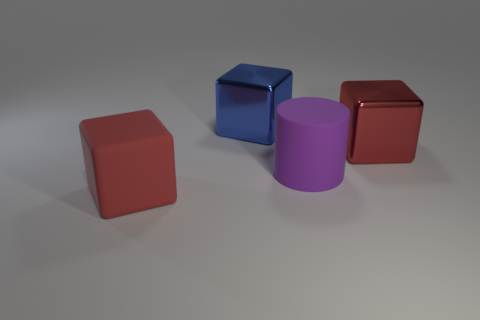The red metallic object that is the same size as the purple cylinder is what shape?
Offer a terse response. Cube. Is there a brown object of the same size as the blue thing?
Your answer should be very brief. No. What is the material of the blue object that is the same size as the purple cylinder?
Give a very brief answer. Metal. There is a red object to the right of the big red block on the left side of the blue cube; what is its size?
Offer a terse response. Large. There is a metal object that is to the right of the purple rubber object; does it have the same size as the big red matte block?
Make the answer very short. Yes. Are there more large cubes to the right of the blue shiny block than large blue cubes in front of the big red shiny block?
Ensure brevity in your answer.  Yes. There is a thing that is both behind the rubber cylinder and on the right side of the big blue thing; what shape is it?
Provide a short and direct response. Cube. What is the shape of the large matte object that is on the right side of the big red rubber cube?
Offer a terse response. Cylinder. There is a red object left of the large purple matte cylinder that is on the right side of the metal object on the left side of the big purple cylinder; what is its size?
Keep it short and to the point. Large. Does the large red rubber object have the same shape as the big blue shiny object?
Your answer should be very brief. Yes. 